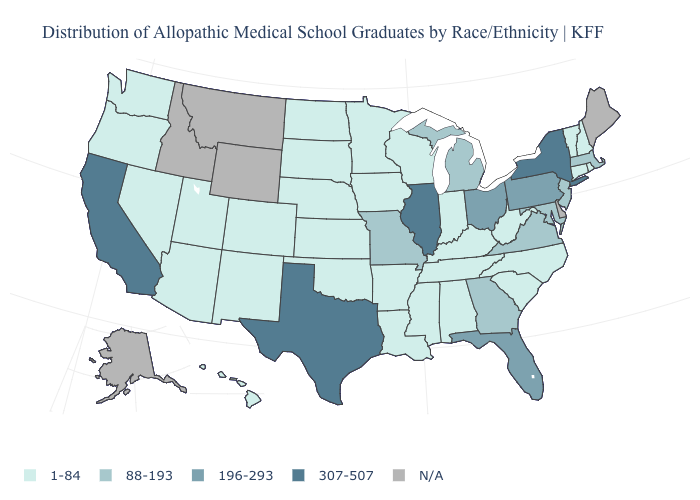Does Illinois have the highest value in the USA?
Give a very brief answer. Yes. What is the highest value in the USA?
Short answer required. 307-507. Name the states that have a value in the range 88-193?
Answer briefly. Georgia, Maryland, Massachusetts, Michigan, Missouri, New Jersey, Virginia. Name the states that have a value in the range 88-193?
Concise answer only. Georgia, Maryland, Massachusetts, Michigan, Missouri, New Jersey, Virginia. Name the states that have a value in the range N/A?
Keep it brief. Alaska, Delaware, Idaho, Maine, Montana, Wyoming. Which states have the highest value in the USA?
Concise answer only. California, Illinois, New York, Texas. What is the value of New Hampshire?
Keep it brief. 1-84. Which states hav the highest value in the MidWest?
Concise answer only. Illinois. Does Kentucky have the highest value in the South?
Be succinct. No. Name the states that have a value in the range 88-193?
Be succinct. Georgia, Maryland, Massachusetts, Michigan, Missouri, New Jersey, Virginia. Does Minnesota have the lowest value in the USA?
Answer briefly. Yes. Does New York have the highest value in the Northeast?
Keep it brief. Yes. Does Illinois have the lowest value in the MidWest?
Concise answer only. No. Among the states that border Florida , does Alabama have the highest value?
Answer briefly. No. 